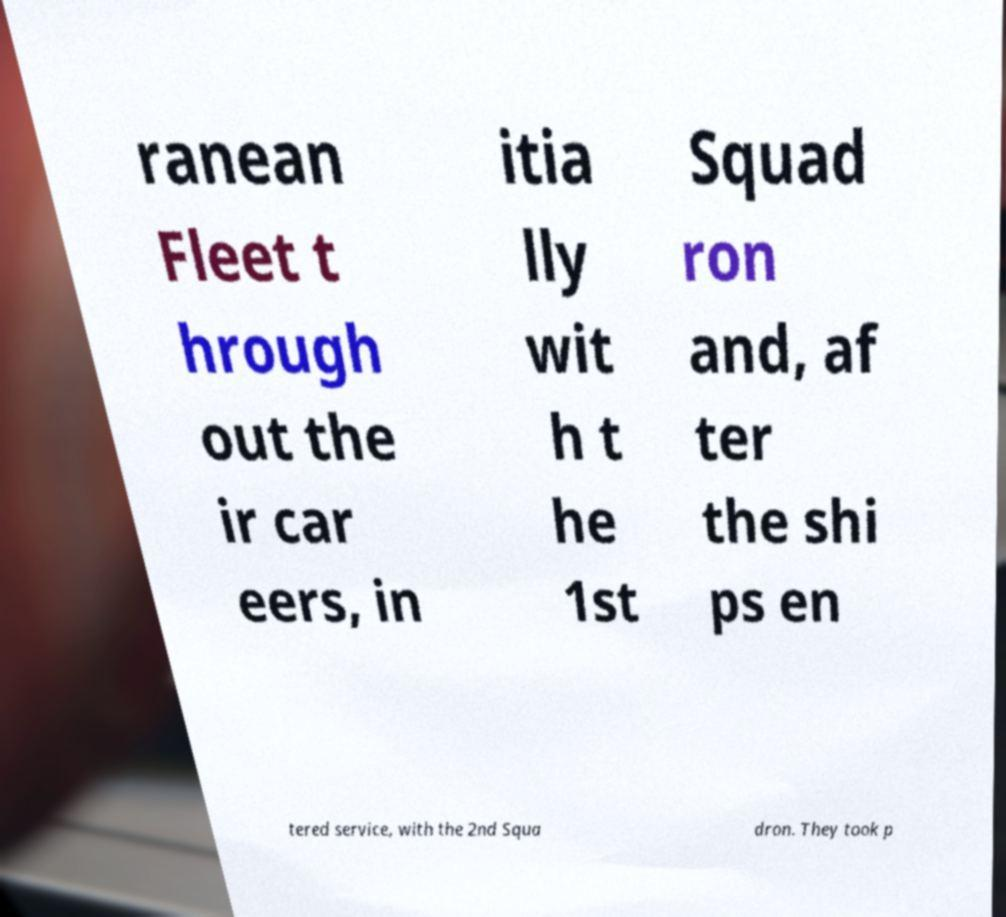Please identify and transcribe the text found in this image. ranean Fleet t hrough out the ir car eers, in itia lly wit h t he 1st Squad ron and, af ter the shi ps en tered service, with the 2nd Squa dron. They took p 